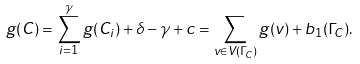<formula> <loc_0><loc_0><loc_500><loc_500>g ( C ) = \sum _ { i = 1 } ^ { \gamma } g ( C _ { i } ) + \delta - \gamma + c = \sum _ { v \in V ( \Gamma _ { C } ) } g ( v ) + b _ { 1 } ( \Gamma _ { C } ) .</formula> 